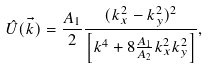<formula> <loc_0><loc_0><loc_500><loc_500>\hat { U } ( \vec { k } ) = \frac { A _ { 1 } } { 2 } \frac { ( k _ { x } ^ { 2 } - k _ { y } ^ { 2 } ) ^ { 2 } } { \left [ k ^ { 4 } + 8 \frac { A _ { 1 } } { A _ { 2 } } k _ { x } ^ { 2 } k _ { y } ^ { 2 } \right ] } ,</formula> 